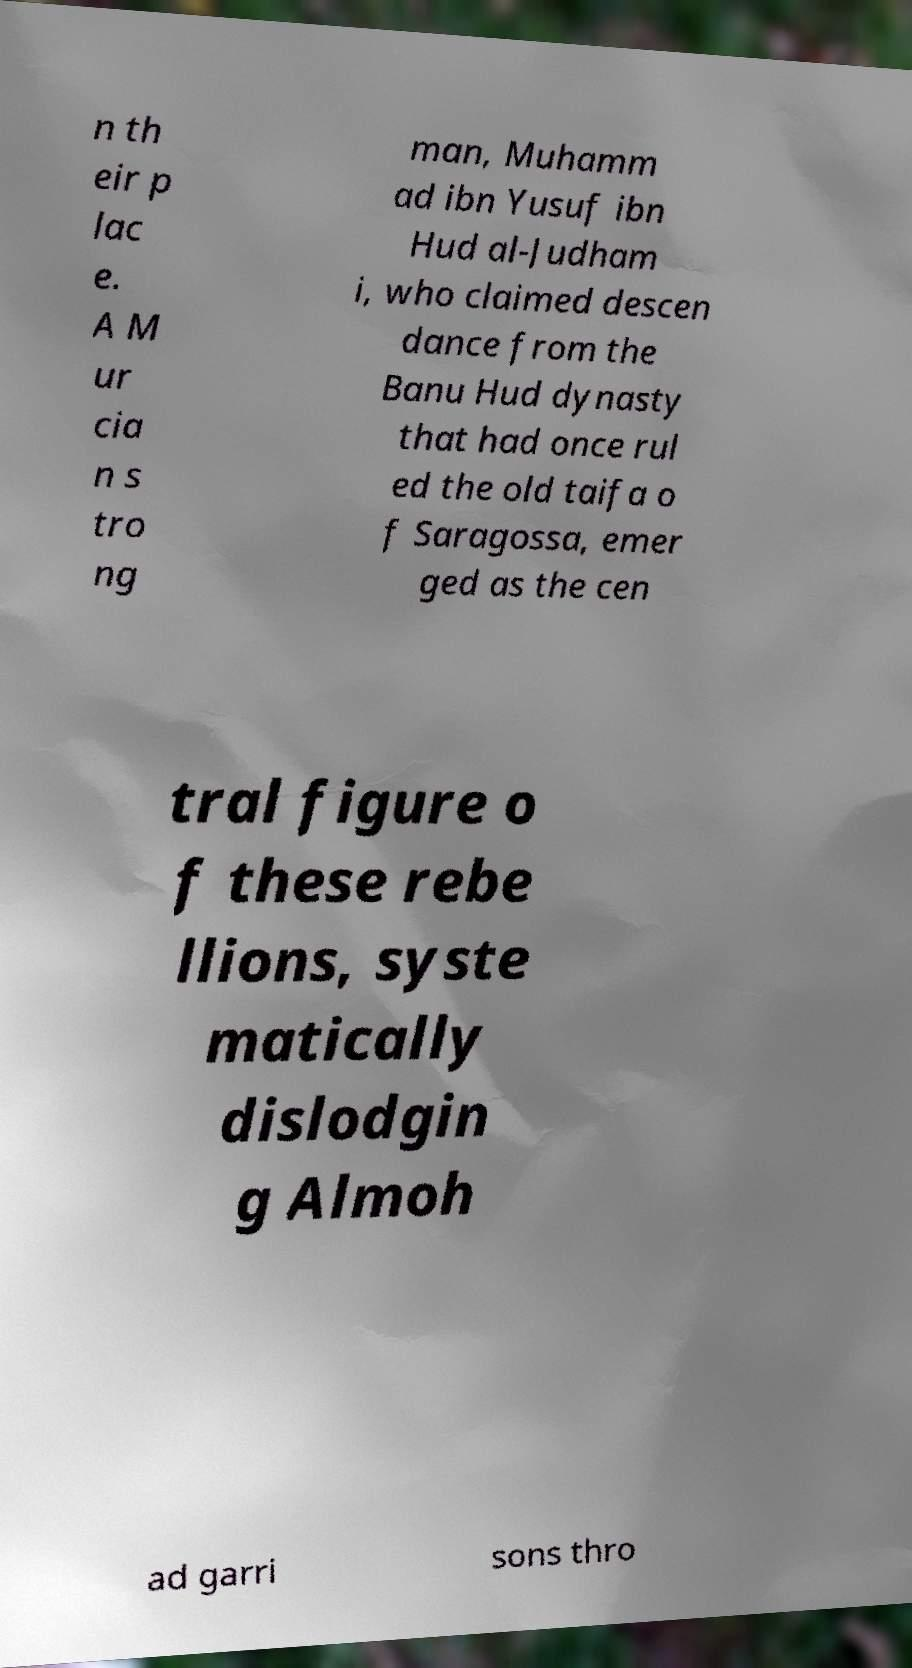For documentation purposes, I need the text within this image transcribed. Could you provide that? n th eir p lac e. A M ur cia n s tro ng man, Muhamm ad ibn Yusuf ibn Hud al-Judham i, who claimed descen dance from the Banu Hud dynasty that had once rul ed the old taifa o f Saragossa, emer ged as the cen tral figure o f these rebe llions, syste matically dislodgin g Almoh ad garri sons thro 